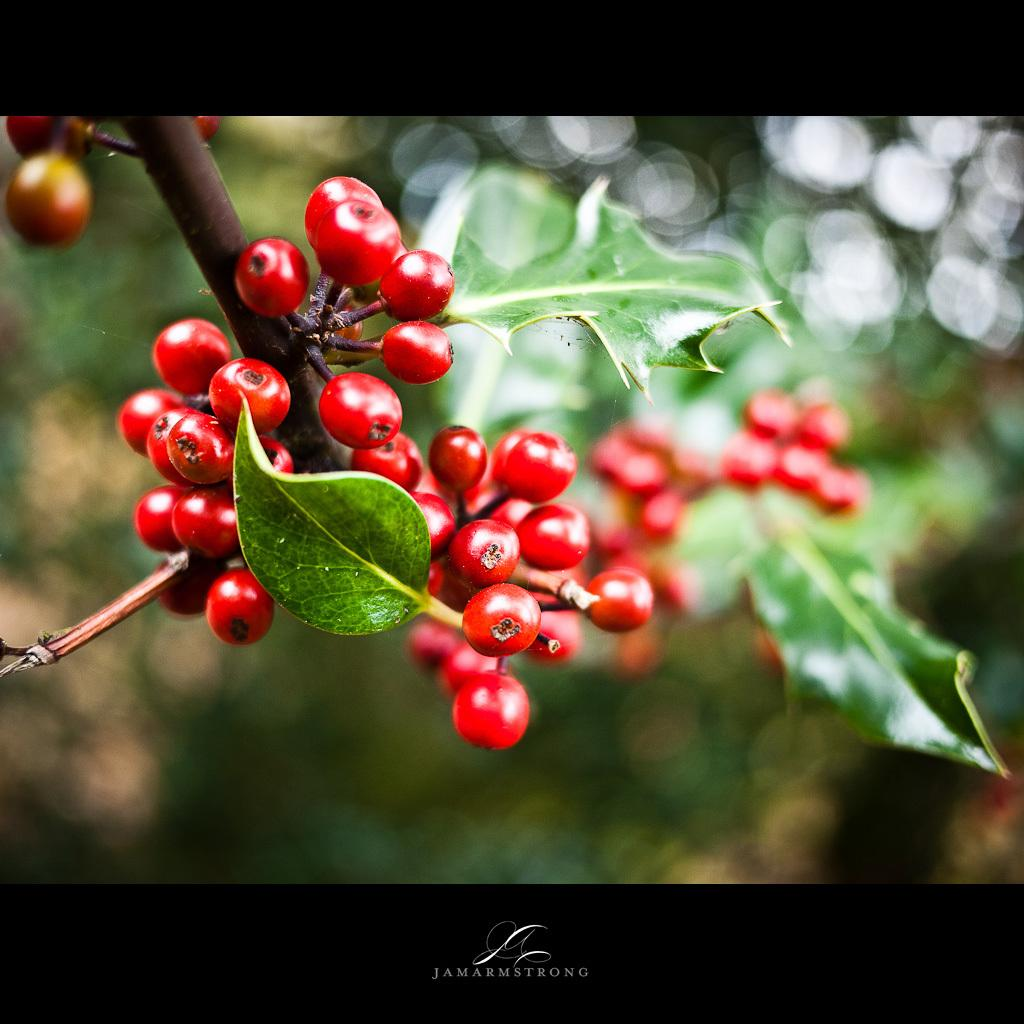What type of tree is present in the image? There is a berry-like fruit tree in the image. What other types of vegetation can be seen in the image? There are plants in the image. What type of vessel is being used to water the plants in the image? There is no vessel visible in the image, as it only shows a berry-like fruit tree and plants. 